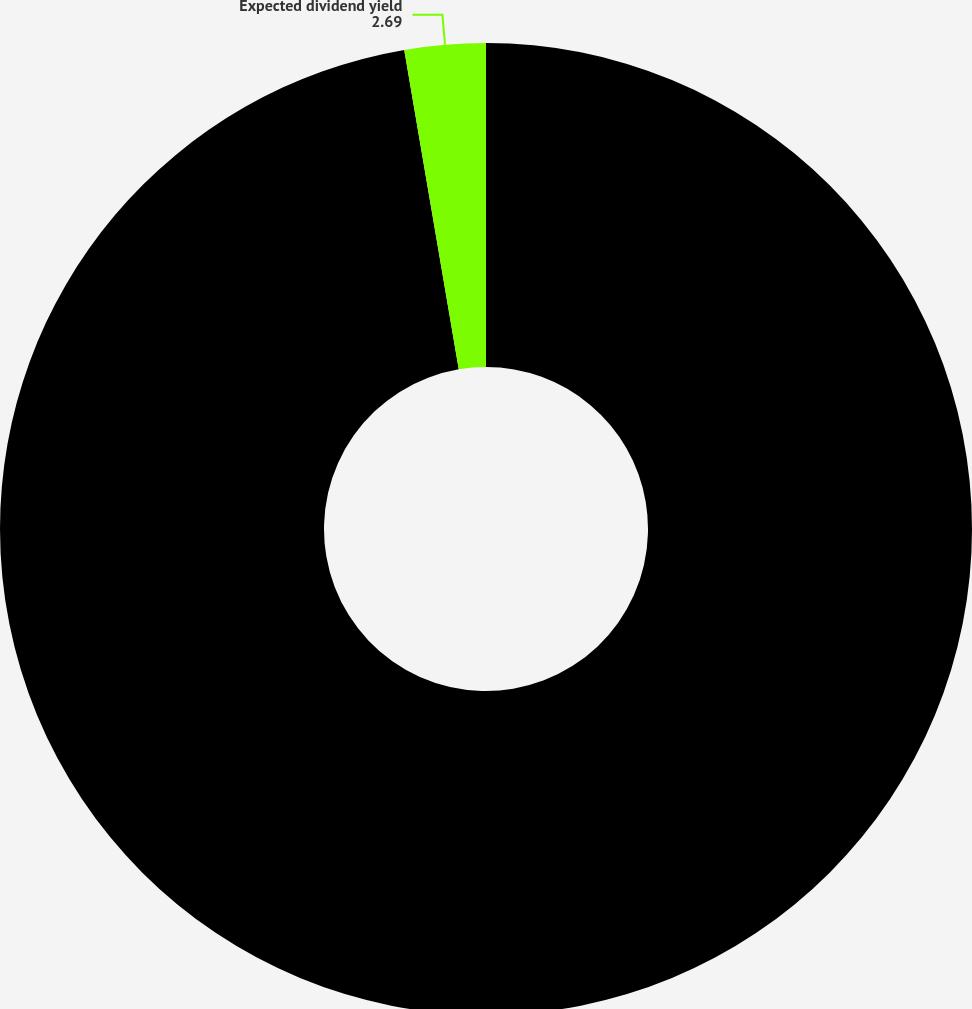Convert chart to OTSL. <chart><loc_0><loc_0><loc_500><loc_500><pie_chart><fcel>Expected volatility<fcel>Expected dividend yield<nl><fcel>97.31%<fcel>2.69%<nl></chart> 